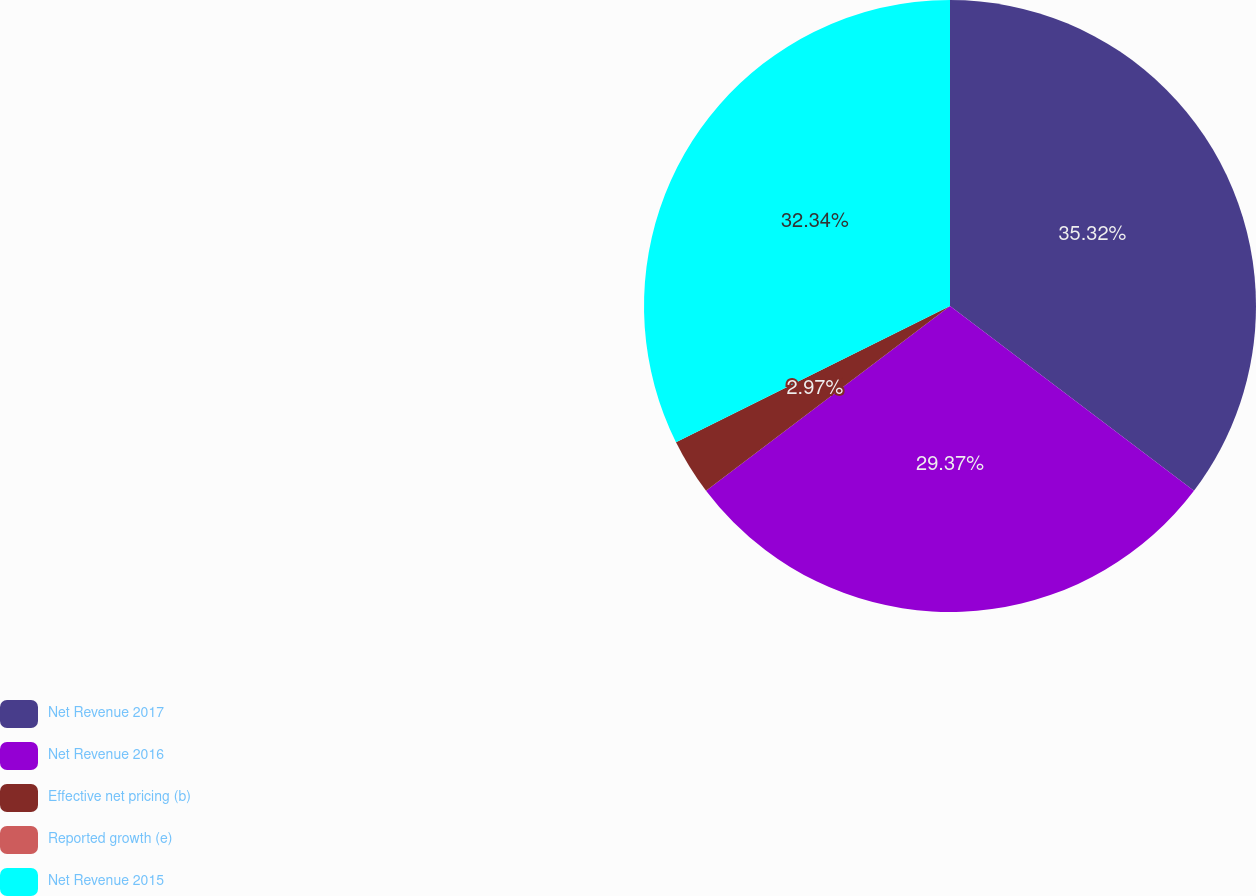Convert chart. <chart><loc_0><loc_0><loc_500><loc_500><pie_chart><fcel>Net Revenue 2017<fcel>Net Revenue 2016<fcel>Effective net pricing (b)<fcel>Reported growth (e)<fcel>Net Revenue 2015<nl><fcel>35.31%<fcel>29.37%<fcel>2.97%<fcel>0.0%<fcel>32.34%<nl></chart> 